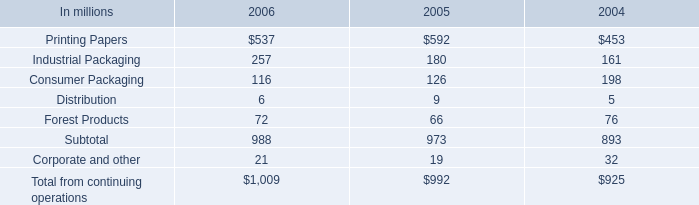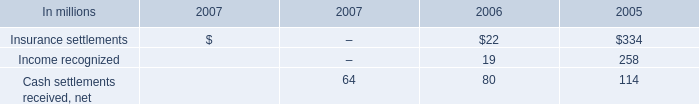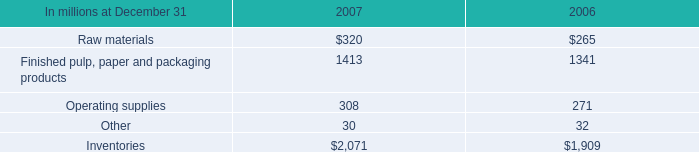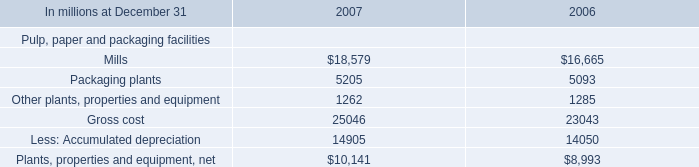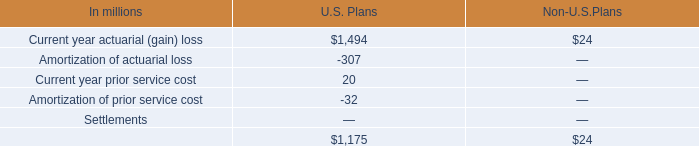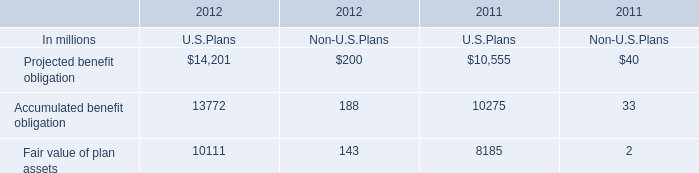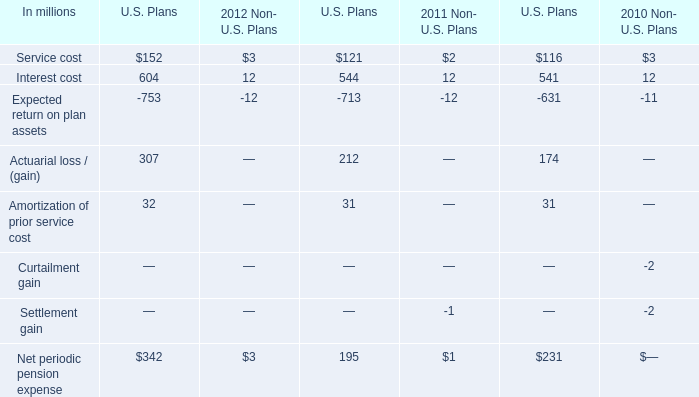What is the sum of Finished pulp, paper and packaging products of 2007, Accumulated benefit obligation of 2011 U.S.Plans, and Mills of 2006 ? 
Computations: ((1413.0 + 10275.0) + 16665.0)
Answer: 28353.0. 